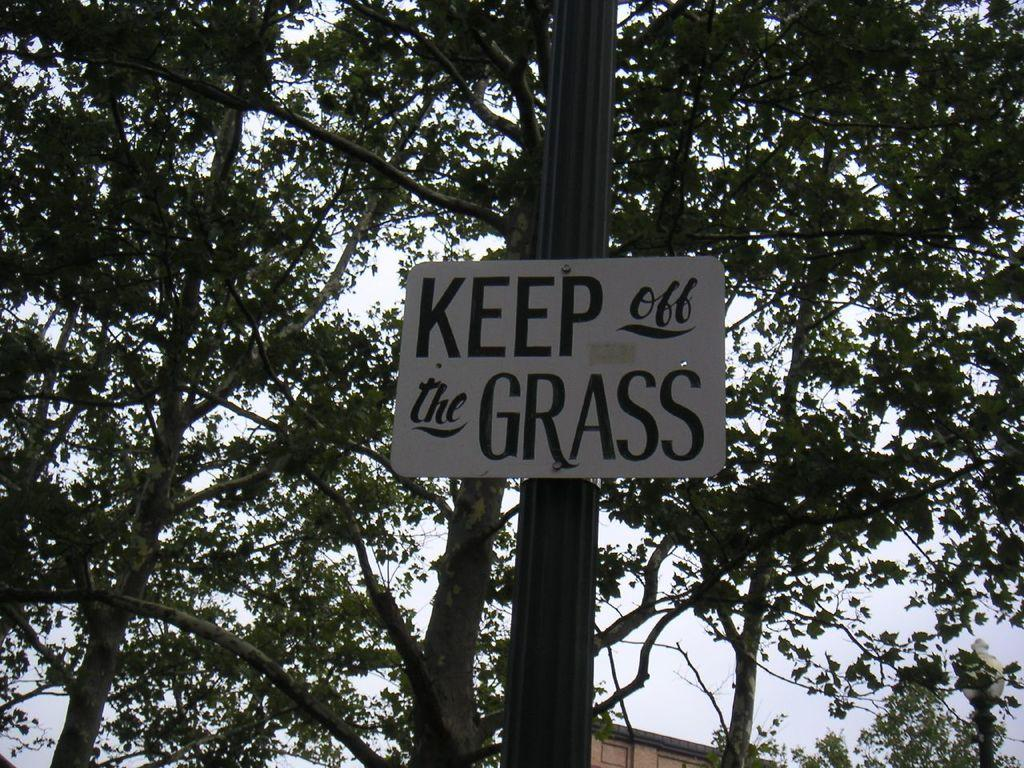What type of vegetation can be seen in the image? There are trees in the image. What is located in the middle of the image? There is a pole in the middle of the image. What is attached to the pole? The pole contains a board. Where is the street lamp located in the image? The street lamp is in the bottom right of the image. Can you tell me how many pens are on the board attached to the pole? There is no pen present on the board attached to the pole in the image. Are there any faucets visible in the image? There are no faucets present in the image. 